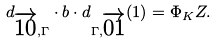<formula> <loc_0><loc_0><loc_500><loc_500>d _ { \overrightarrow { 1 0 } , \Gamma } \cdot b \cdot d _ { \Gamma , \overrightarrow { 0 1 } } ( 1 ) = \Phi _ { K } Z .</formula> 